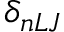<formula> <loc_0><loc_0><loc_500><loc_500>\delta _ { n L J }</formula> 